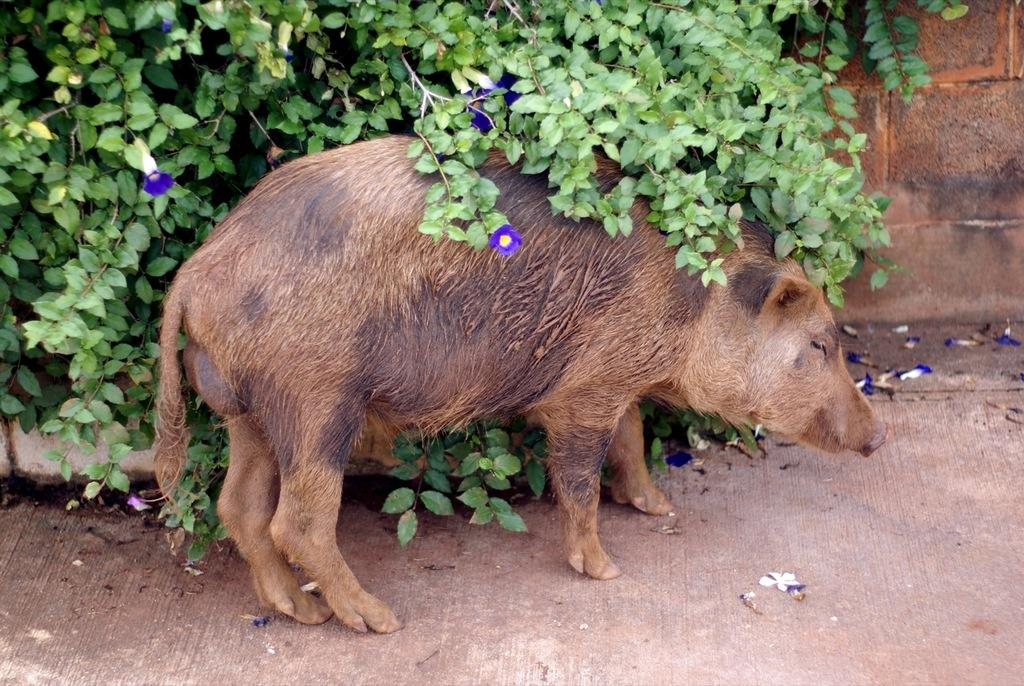What animal is in the front of the image? There is a pig in the front of the image. What type of vegetation is on the left side of the image? There are leaves and flowers on the left side of the image. What structure is on the right side of the image? There is a wall on the right side of the image. What type of mark can be seen on the pig's back in the image? There is no mark visible on the pig's back in the image. How does the pig crush the leaves and flowers on the left side of the image? The pig does not crush the leaves and flowers in the image; it is not interacting with them. 